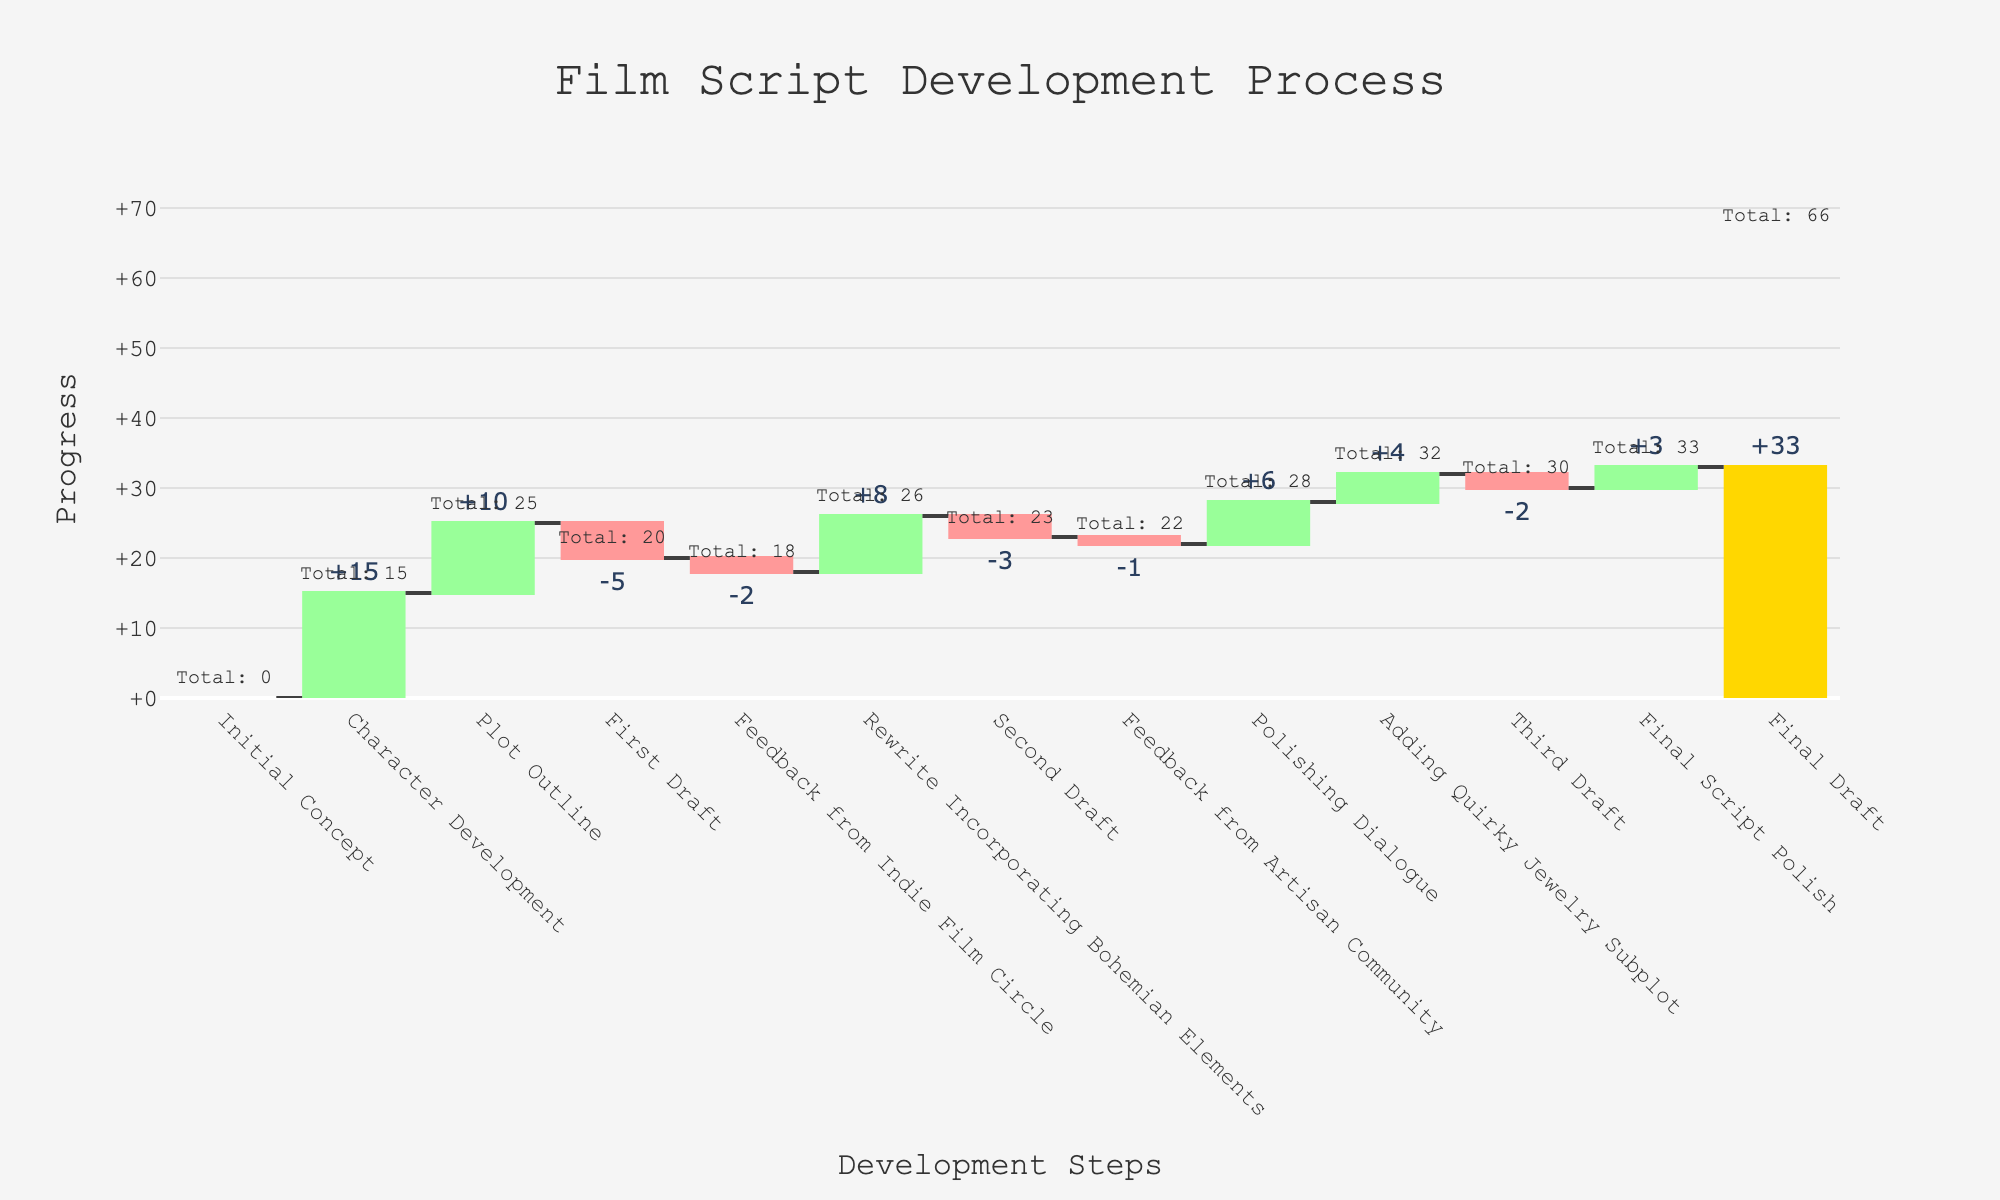How many development steps are displayed in the chart? Count the number of steps (bars) in the chart. There are 13 steps visible in the chart.
Answer: 13 What is the overall progress from the Initial Concept to the Final Draft? Look at the cumulative values; the initial concept starts at 0, and the final draft is at 33. The overall progress is 33.
Answer: 33 Which step added the most progress? Identify the step with the highest positive value. "Character Development" added 15 progress.
Answer: Character Development Which step contributed the least progress? Identify the step with the highest negative value. "First Draft" subtracted 5 progress.
Answer: First Draft How many steps resulted in decreases in progress? Count the number of steps with negative values. There are 4 steps where progress decreased ("First Draft", "Second Draft", "Feedback from Indie Film Circle", "Feedback from Artisan Community", "Third Draft").
Answer: 4 What is the cumulative progress after the "Plot Outline"? Add the values of the steps up to and including the "Plot Outline". The cumulative progress is 0 + 15 + 10 = 25.
Answer: 25 At what step does the cumulative progress first drop below 20? Check each step's cumulative progress to find when it first falls below 20. After "Feedback from Indie Film Circle", the cumulative progress drops to 18.
Answer: Feedback from Indie Film Circle How much progress was made between "Feedback from Indie Film Circle" and "Final Script Polish"? Calculate the difference in cumulative progress between these two steps. Feedback from Indie Film Circle: 18 − 2 = 16, Polishing Dialogue: 23 + 6 = 29, Adding Quirky Jewelry Subplot: 29 + 4 = 33, Third Draft: 35 -2 33. The Final cumulative progress at "Final Script Polish" is 35.
Answer: +18 Which development step added 8 progress points? Look at the values for each step. "Rewrite Incorporating Bohemian Elements" added 8 progress points.
Answer: Rewrite Incorporating Bohemian Elements What is the net effect of all feedback steps? Sum the values of the feedback steps. Indie Film Circle: −2, Artisan Community: −1, Total: −2 -1= −3.
Answer: −3 